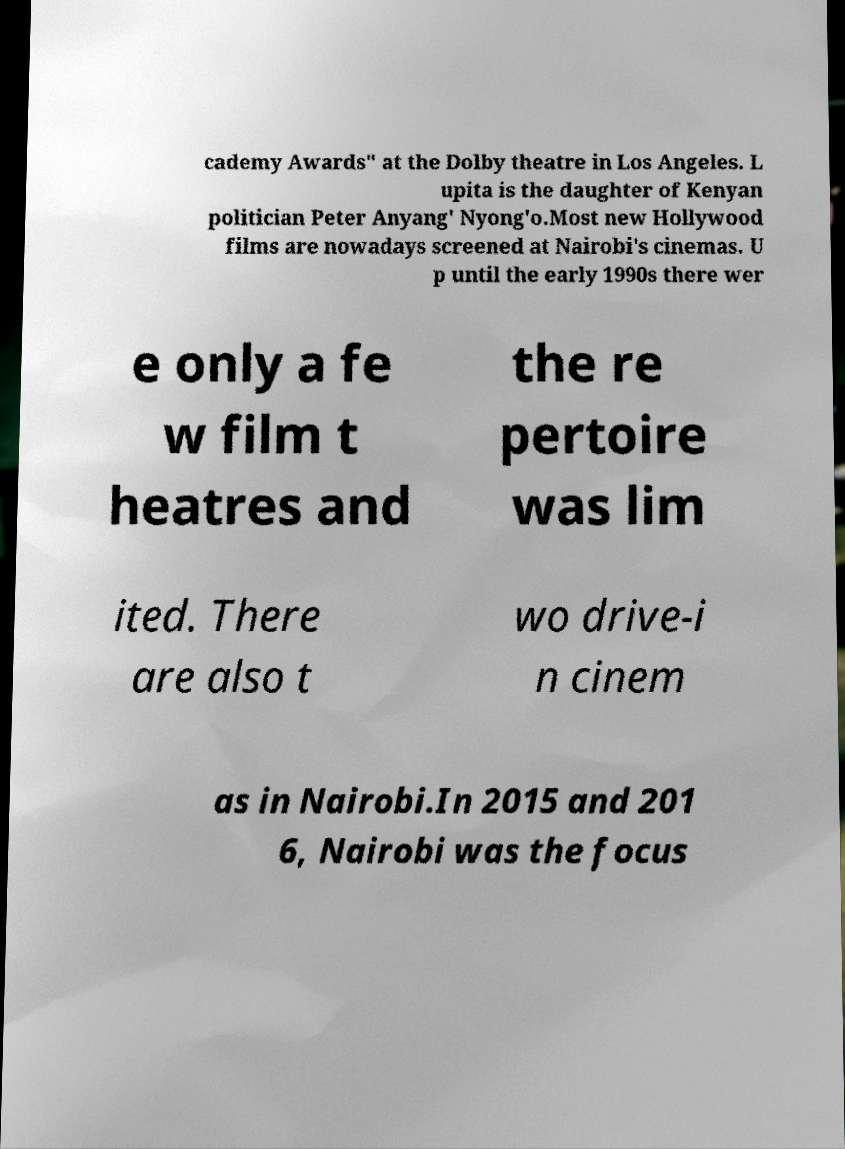Could you extract and type out the text from this image? cademy Awards" at the Dolby theatre in Los Angeles. L upita is the daughter of Kenyan politician Peter Anyang' Nyong'o.Most new Hollywood films are nowadays screened at Nairobi's cinemas. U p until the early 1990s there wer e only a fe w film t heatres and the re pertoire was lim ited. There are also t wo drive-i n cinem as in Nairobi.In 2015 and 201 6, Nairobi was the focus 